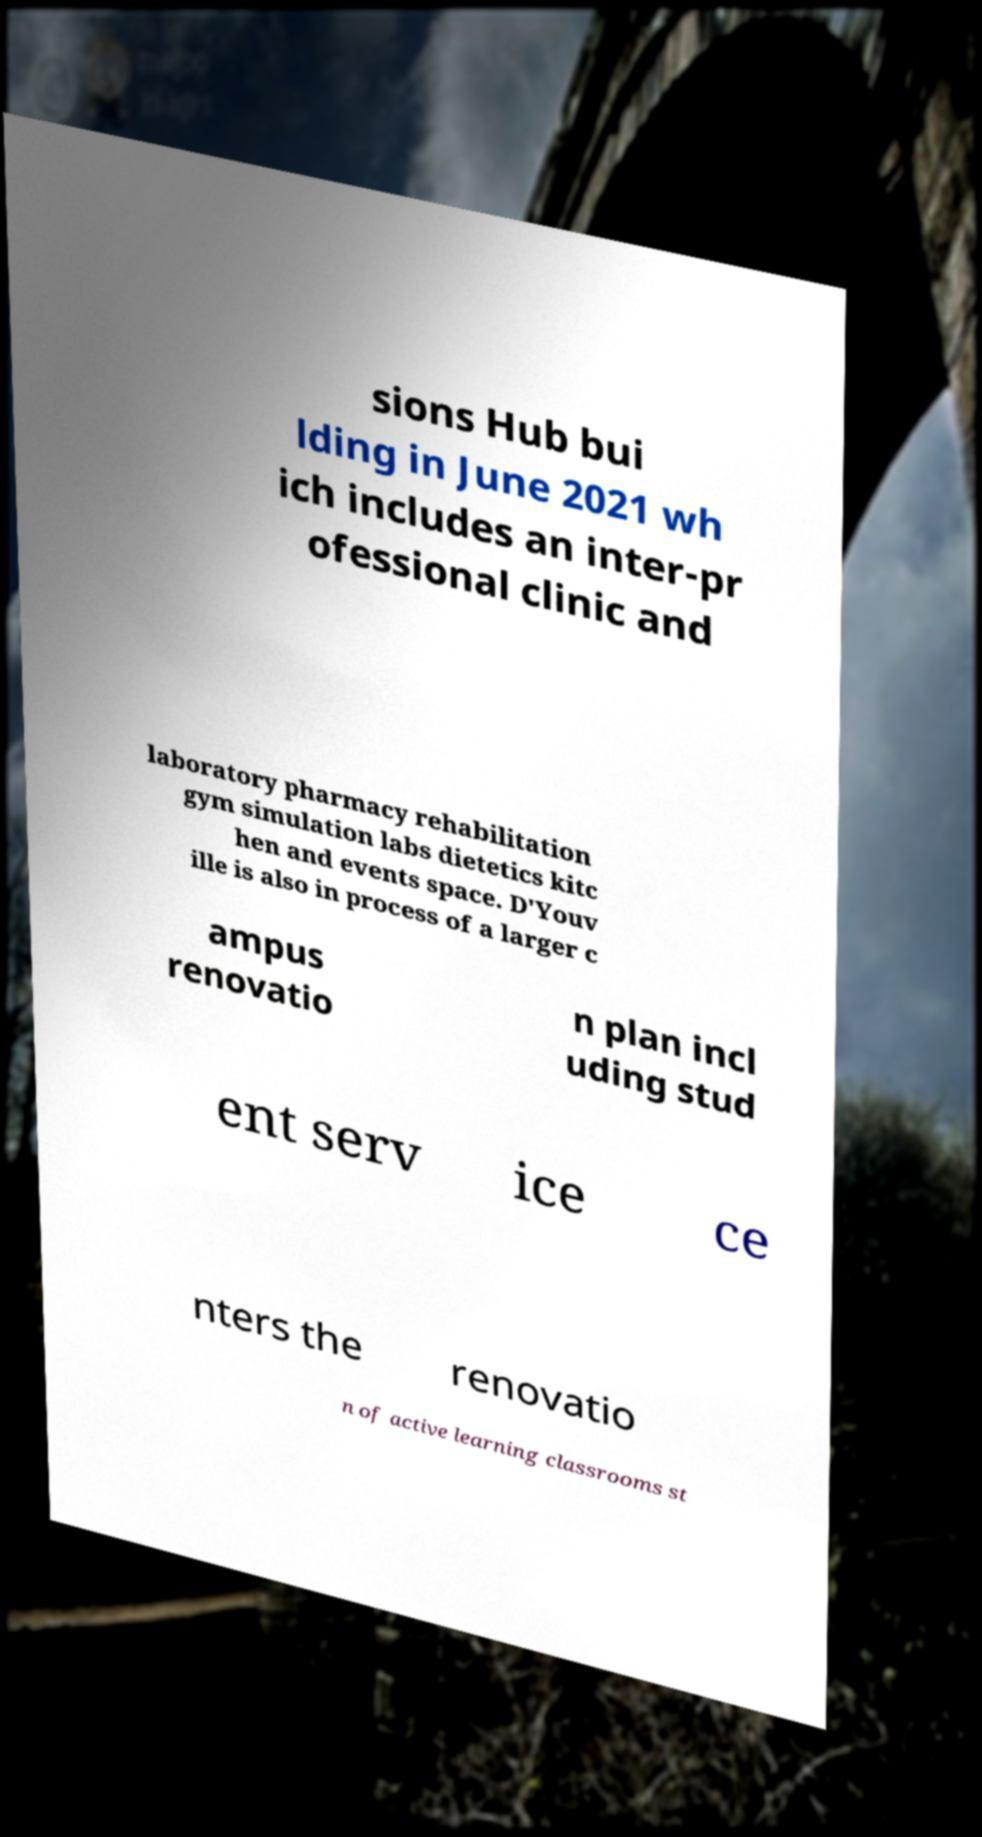What messages or text are displayed in this image? I need them in a readable, typed format. sions Hub bui lding in June 2021 wh ich includes an inter-pr ofessional clinic and laboratory pharmacy rehabilitation gym simulation labs dietetics kitc hen and events space. D'Youv ille is also in process of a larger c ampus renovatio n plan incl uding stud ent serv ice ce nters the renovatio n of active learning classrooms st 